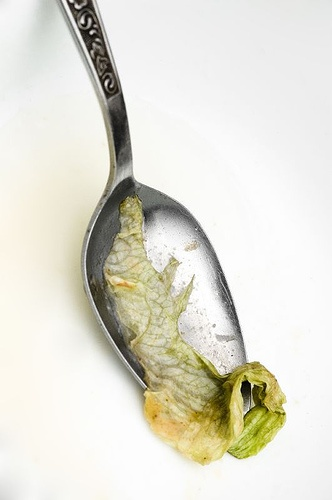Describe the objects in this image and their specific colors. I can see a spoon in lightgray, white, gray, darkgray, and black tones in this image. 